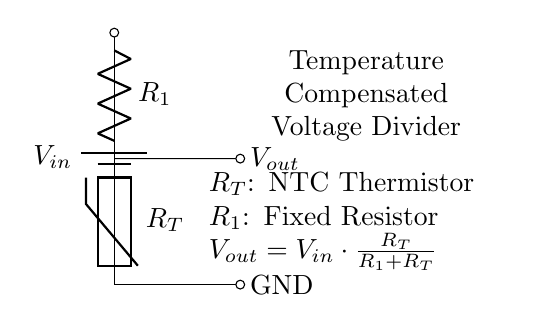What type of thermistor is used in this circuit? The circuit diagram indicates an NTC (Negative Temperature Coefficient) thermistor, noted by the label $R_T$. NTC thermistors decrease their resistance as the temperature increases.
Answer: NTC thermistor What is the value of $V_{out}$ based on the voltage divider formula? The output voltage $V_{out}$ is calculated using the formula $V_{out} = V_{in} \cdot \frac{R_T}{R_1 + R_T}$. This shows that $V_{out}$ depends on both $V_{in}$ and the resistances.
Answer: $V_{out} = V_{in} \cdot \frac{R_T}{R_1 + R_T}$ What is the role of the fixed resistor $R_1$? The fixed resistor $R_1$ is part of the voltage divider that stabilizes the output voltage when the resistance of the thermistor $R_T$ varies with temperature. It helps to define the division of the input voltage among the two resistors in the circuit.
Answer: Stabilizing output voltage Why is temperature compensation important in this circuit? Temperature compensation is crucial because biometric sensor operations can be sensitive to temperature changes. The NTC thermistor helps maintain consistent performance of the sensor by adjusting the output voltage according to variations in temperature, which ensures reliable readings.
Answer: To maintain consistent sensor performance What is the overall function of this circuit? The overall function of the voltage divider circuit is to provide a stable output voltage $V_{out}$ that can be used to power or signal the operation of a biometric sensor, tailored by the temperature effect on the thermistor $R_T$.
Answer: To provide stable output voltage How does the resistance of the thermistor change with temperature? The resistance of an NTC thermistor decreases as the temperature increases. This characteristic allows the circuit to adjust $V_{out}$ dynamically, ensuring the output is stable even when operating conditions vary.
Answer: It decreases as temperature increases 